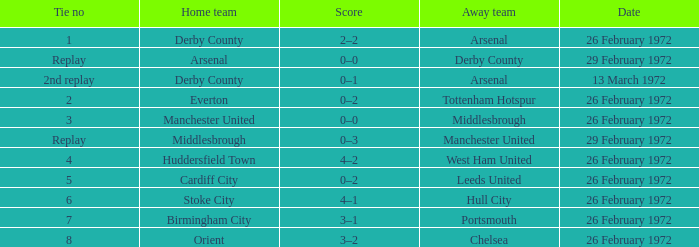Which Tie is from birmingham city? 7.0. I'm looking to parse the entire table for insights. Could you assist me with that? {'header': ['Tie no', 'Home team', 'Score', 'Away team', 'Date'], 'rows': [['1', 'Derby County', '2–2', 'Arsenal', '26 February 1972'], ['Replay', 'Arsenal', '0–0', 'Derby County', '29 February 1972'], ['2nd replay', 'Derby County', '0–1', 'Arsenal', '13 March 1972'], ['2', 'Everton', '0–2', 'Tottenham Hotspur', '26 February 1972'], ['3', 'Manchester United', '0–0', 'Middlesbrough', '26 February 1972'], ['Replay', 'Middlesbrough', '0–3', 'Manchester United', '29 February 1972'], ['4', 'Huddersfield Town', '4–2', 'West Ham United', '26 February 1972'], ['5', 'Cardiff City', '0–2', 'Leeds United', '26 February 1972'], ['6', 'Stoke City', '4–1', 'Hull City', '26 February 1972'], ['7', 'Birmingham City', '3–1', 'Portsmouth', '26 February 1972'], ['8', 'Orient', '3–2', 'Chelsea', '26 February 1972']]} 